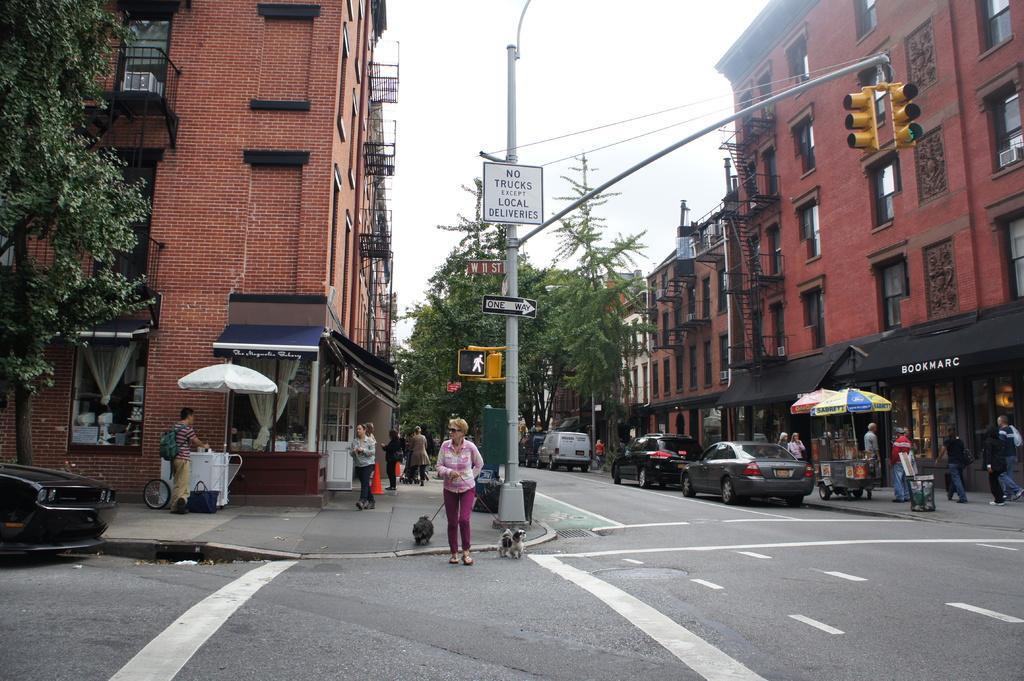Could you give a brief overview of what you see in this image? In the center of the image there is a person walking on the road by holding the dogs. Behind her there are few other people. There are cars parked on the road. There are traffic signals, signal boards, sign boards. On the right side of the image there are stores. In front of the stores there are a few people walking on the pavement. In the background of the image there are buildings, trees and sky. 